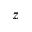<formula> <loc_0><loc_0><loc_500><loc_500>z</formula> 